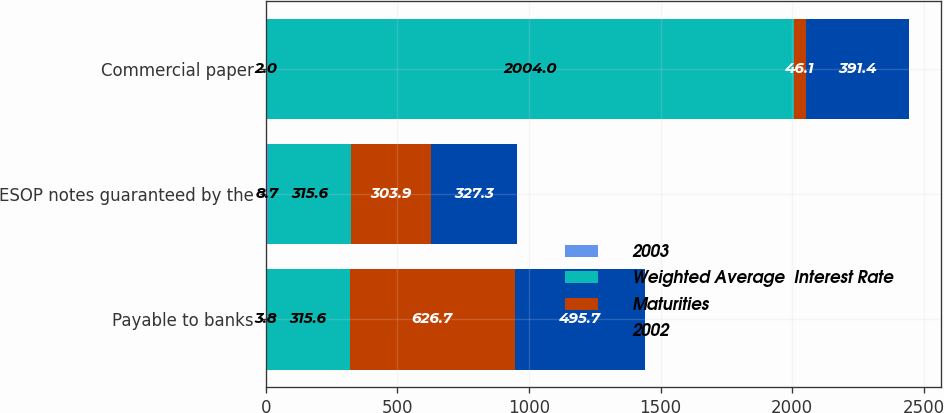Convert chart to OTSL. <chart><loc_0><loc_0><loc_500><loc_500><stacked_bar_chart><ecel><fcel>Payable to banks<fcel>ESOP notes guaranteed by the<fcel>Commercial paper<nl><fcel>2003<fcel>3.8<fcel>8.7<fcel>2<nl><fcel>Weighted Average  Interest Rate<fcel>315.6<fcel>315.6<fcel>2004<nl><fcel>Maturities<fcel>626.7<fcel>303.9<fcel>46.1<nl><fcel>2002<fcel>495.7<fcel>327.3<fcel>391.4<nl></chart> 